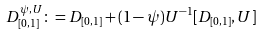<formula> <loc_0><loc_0><loc_500><loc_500>D ^ { \psi , U } _ { [ 0 , 1 ] } \colon = D _ { [ 0 , 1 ] } + ( 1 - \psi ) U ^ { - 1 } [ D _ { [ 0 , 1 ] } , U ]</formula> 